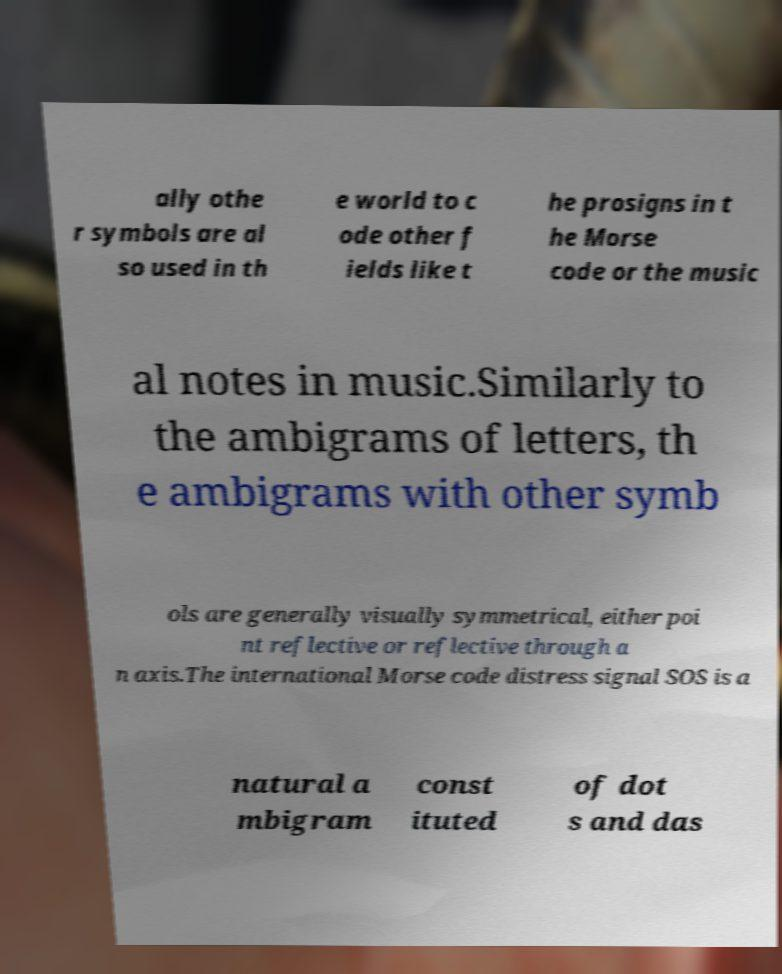What messages or text are displayed in this image? I need them in a readable, typed format. ally othe r symbols are al so used in th e world to c ode other f ields like t he prosigns in t he Morse code or the music al notes in music.Similarly to the ambigrams of letters, th e ambigrams with other symb ols are generally visually symmetrical, either poi nt reflective or reflective through a n axis.The international Morse code distress signal SOS is a natural a mbigram const ituted of dot s and das 